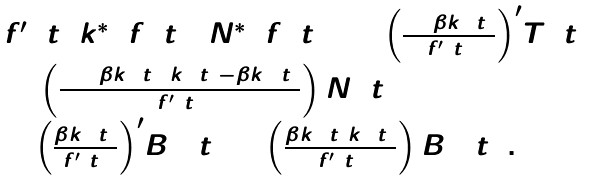<formula> <loc_0><loc_0><loc_500><loc_500>\begin{array} { l } f ^ { \prime } \left ( t \right ) k _ { 1 } ^ { * } \left ( { f \left ( t \right ) } \right ) { N ^ { * } } \left ( { f \left ( t \right ) } \right ) = { \left ( { \frac { { 1 + \beta { k _ { 1 } } \left ( t \right ) } } { f ^ { \prime } \left ( t \right ) } } \right ) ^ { \prime } } T \left ( t \right ) \\ \, + \left ( { \frac { { \left ( { 1 + \beta { k _ { 1 } } \left ( t \right ) } \right ) { k _ { 1 } } \left ( t \right ) - \beta k _ { 2 } ^ { 2 } \left ( t \right ) } } { f ^ { \prime } \left ( t \right ) } } \right ) N \left ( t \right ) \\ \, + { \left ( { \frac { { \beta { k _ { 2 } } \left ( t \right ) } } { f ^ { \prime } \left ( t \right ) } } \right ) ^ { \prime } } { B _ { 1 } } \left ( t \right ) + \left ( { \frac { { \beta { k _ { 2 } } \left ( t \right ) { k _ { 3 } } \left ( t \right ) } } { f ^ { \prime } \left ( t \right ) } } \right ) { B _ { 2 } } \left ( t \right ) . \\ \end{array}</formula> 